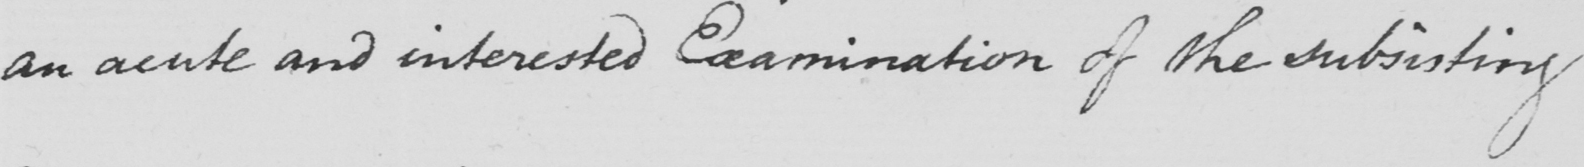Can you tell me what this handwritten text says? an acute and interested Examination of the subsisting 